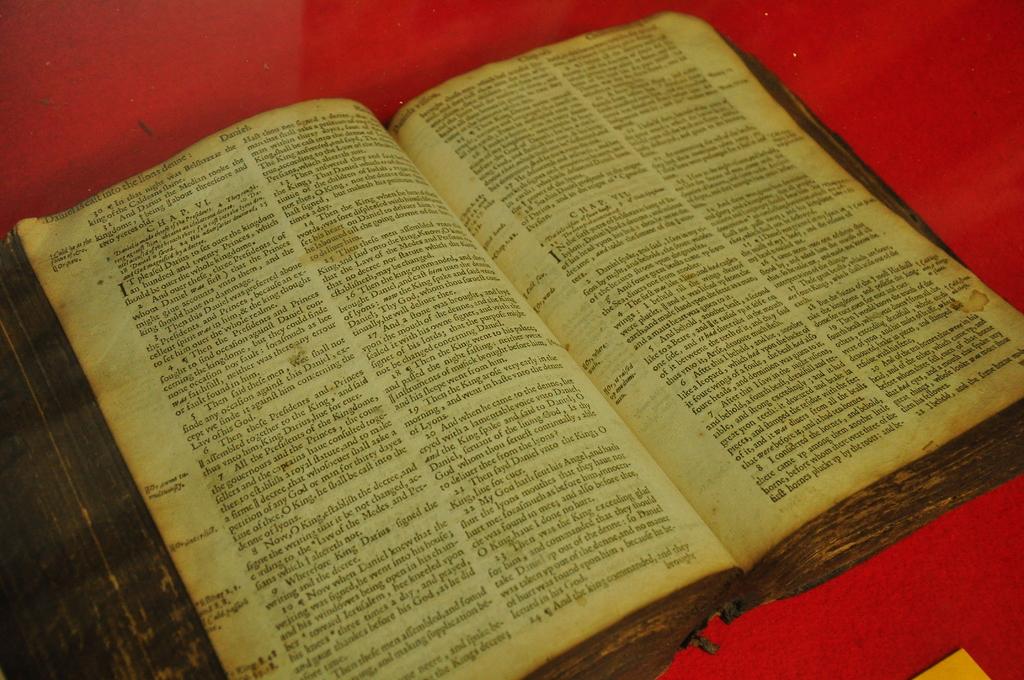What book is the book open to?
Offer a very short reply. Unanswerable. 